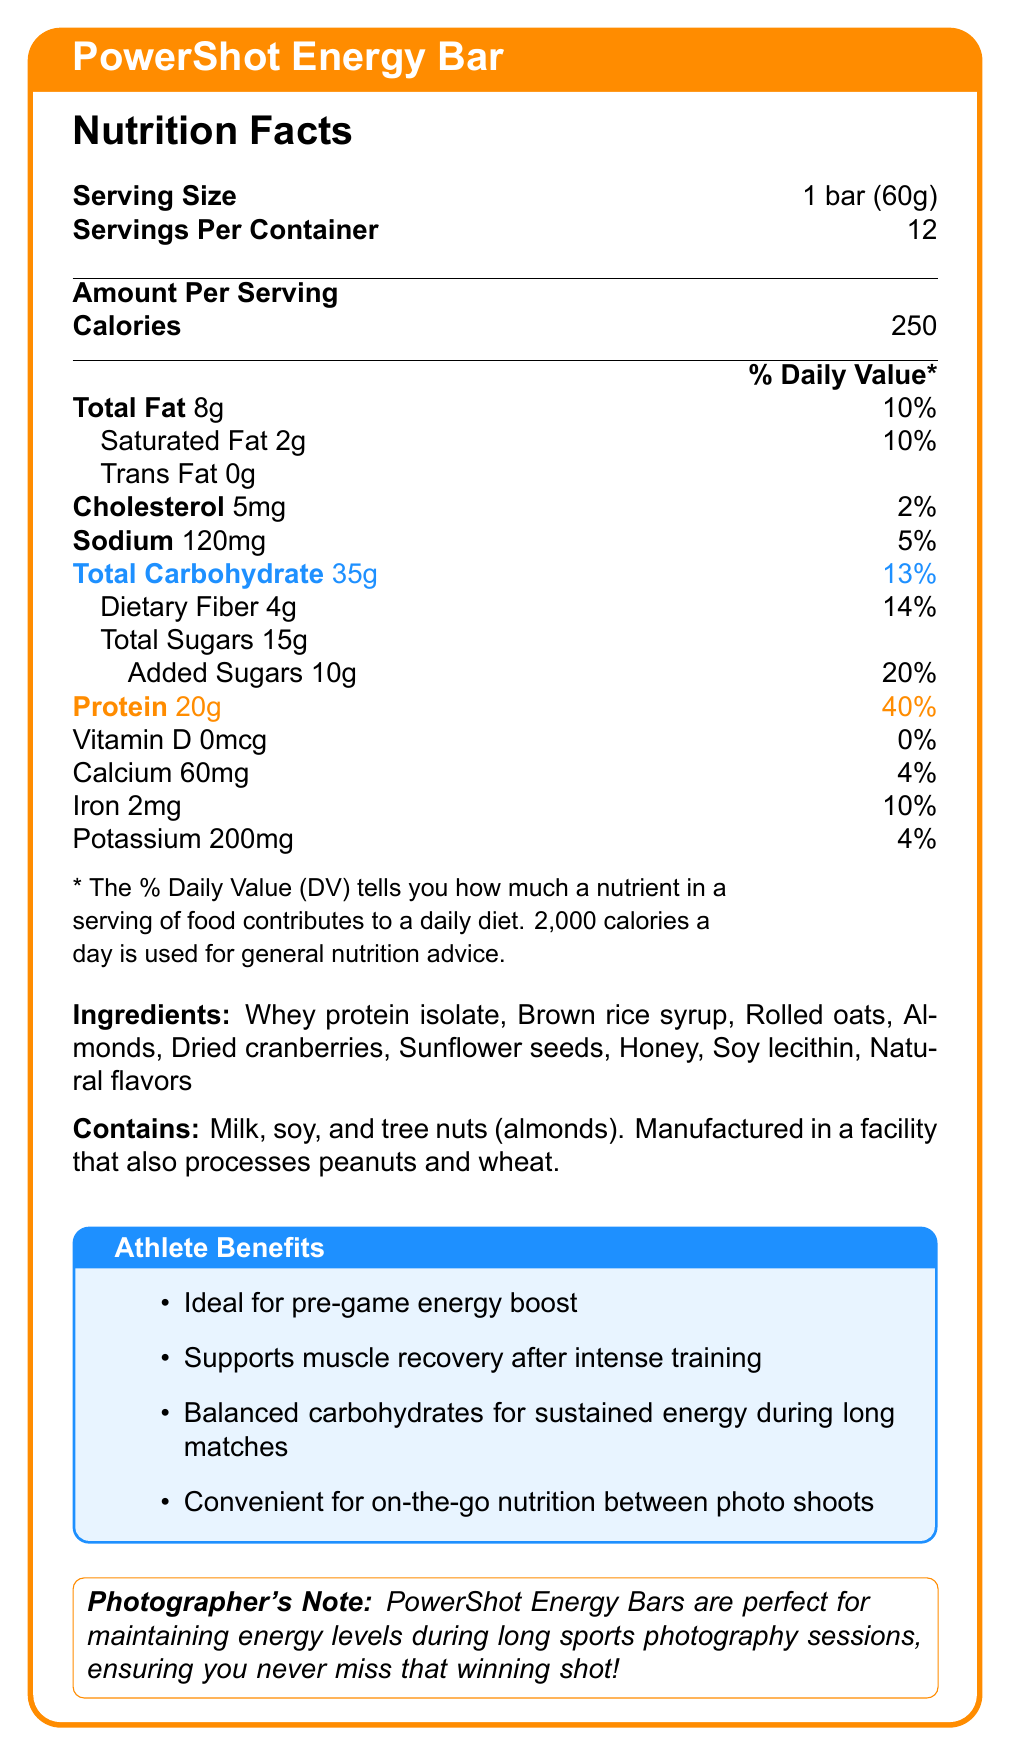what is the serving size of the PowerShot Energy Bar? The document explicitly states that the serving size of the PowerShot Energy Bar is 1 bar, which weighs 60 grams.
Answer: 1 bar (60g) how many calories are in one serving of the PowerShot Energy Bar? The document lists the calorie content as 250 calories for one serving, which is one bar.
Answer: 250 how much total carbohydrate is in one serving? The document specifies that each serving of the energy bar contains 35 grams of total carbohydrate.
Answer: 35g what percentage of the daily value for protein does one bar provide? The document shows that one bar provides 20 grams of protein, which is 40% of the daily value.
Answer: 40% what are the three main allergens listed in the PowerShot Energy Bar? The document states that the bar contains milk, soy, and tree nuts (almonds).
Answer: Milk, soy, and tree nuts (almonds) how many servings are in one container? The document indicates that there are 12 servings per container.
Answer: 12 how much dietary fiber does one serving contain? The document shows that one bar contains 4 grams of dietary fiber.
Answer: 4g does the PowerShot Energy Bar have any added sugars? The document lists added sugars as 10 grams per serving.
Answer: Yes which ingredient is listed first? The first ingredient listed in the document is whey protein isolate.
Answer: Whey protein isolate how much sodium is in one bar? The document indicates that one bar contains 120 milligrams of sodium.
Answer: 120mg which nutrient contributes the highest percentage to the daily value per serving? A. Total Fat B. Protein C. Iron D. Carbohydrate The document shows that protein contributes 40% to the daily value, which is higher than any other listed nutrient.
Answer: B. Protein how much iron is provided per serving of the PowerShot Energy Bar? A. 4% B. 10% C. 20% D. 14% The document states that one serving provides 2 mg of iron, equating to 10% of the daily value.
Answer: B. 10% is the PowerShot Energy Bar ideal for pre-game energy boosts? The document mentions that the bar is ideal for pre-game energy boosts as one of its athlete benefits.
Answer: Yes what specific benefit does the document list for post-training from consuming this energy bar? The document states that the energy bar supports muscle recovery after intense training.
Answer: Supports muscle recovery after intense training what types of flavors are used in the PowerShot Energy Bar? The document lists natural flavors as one of the ingredients.
Answer: Natural flavors summarize the main idea of the document. The document provides comprehensive information on the PowerShot Energy Bar, focusing on its nutritional content, ingredients, allergens, and specific benefits for athletic performance and recovery, along with an additional note on its suitability for photographers.
Answer: The document details the nutritional information, ingredients, allergens, and benefits of the PowerShot Energy Bar, emphasizing its suitability for athletes in need of energy and muscle recovery. It highlights its high protein and carbohydrate content, ideal for pre-game and post-training, and mentions its convenience for photographers needing sustained energy. what is the exact sugar content in grams? The document states that each bar contains a total of 15 grams of sugars.
Answer: 15g does the PowerShot Energy Bar contain any trans fat? The document specifies that the bar contains 0 grams of trans fat.
Answer: No where is the PowerShot Energy Bar ideal to be used according to the photographer's note? The photographer's note in the document states that the bar is perfect for maintaining energy levels during long sports photography sessions.
Answer: During long sports photography sessions how many milligrams of calcium does one serving of the PowerShot Energy Bar provide? The document states that one serving contains 60 milligrams of calcium.
Answer: 60mg how many grams of rolled oats are in the PowerShot Energy Bar? The document lists rolled oats as one of the ingredients but does not specify the quantity in grams.
Answer: Cannot be determined does the PowerShot Energy Bar provide any vitamin D? The document indicates that the bar contains 0 mcg of vitamin D, which is 0% of the daily value.
Answer: No 